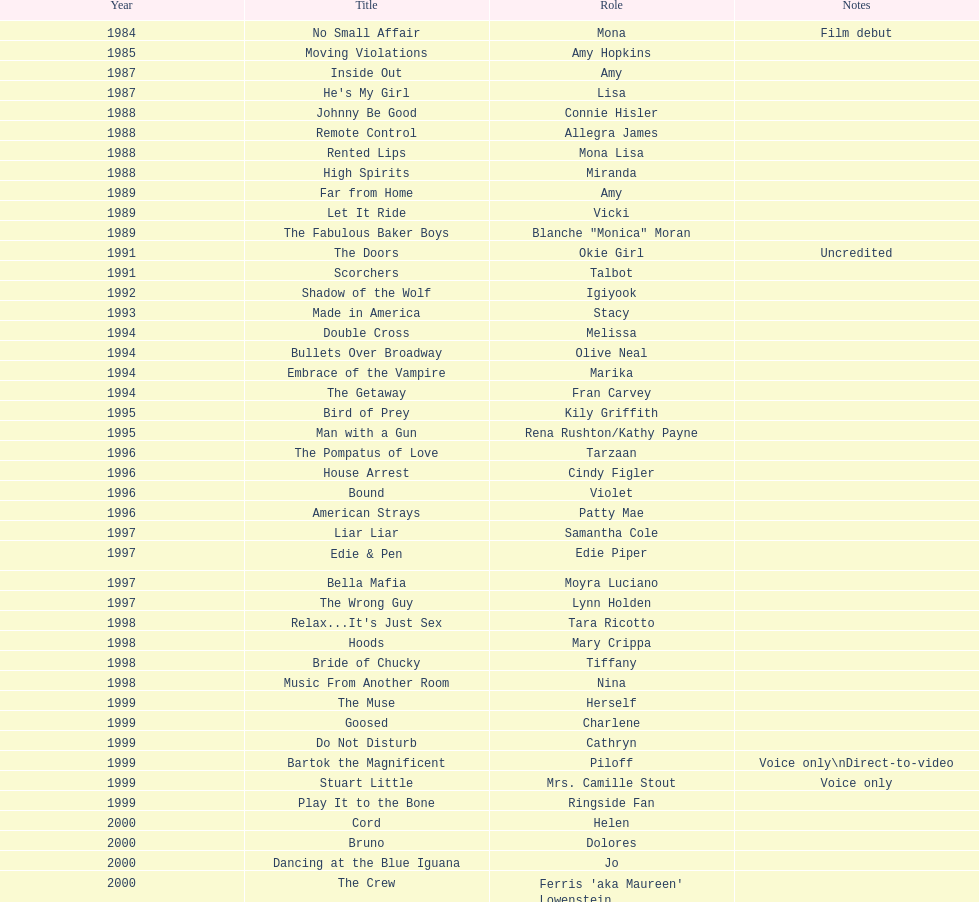In the 1980s, how many roles did jennifer tilly portray? 11. 